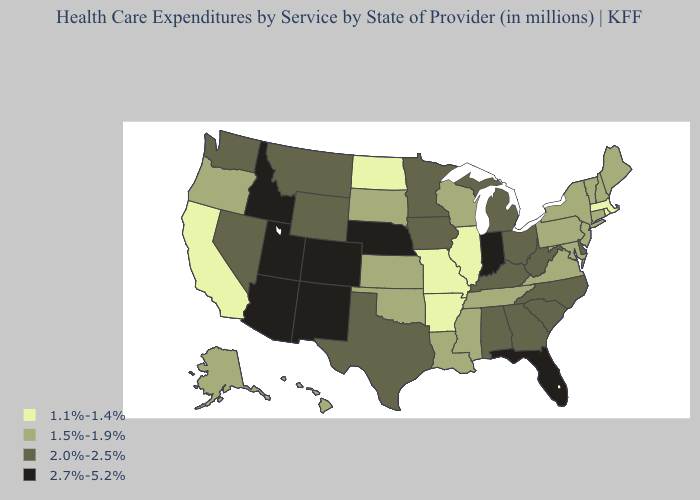Does Iowa have a lower value than Pennsylvania?
Write a very short answer. No. Does South Dakota have the lowest value in the USA?
Quick response, please. No. Does the map have missing data?
Keep it brief. No. Does the map have missing data?
Answer briefly. No. Name the states that have a value in the range 2.7%-5.2%?
Be succinct. Arizona, Colorado, Florida, Idaho, Indiana, Nebraska, New Mexico, Utah. Does Georgia have the lowest value in the South?
Keep it brief. No. Which states have the lowest value in the Northeast?
Answer briefly. Massachusetts, Rhode Island. What is the value of Rhode Island?
Quick response, please. 1.1%-1.4%. Among the states that border Georgia , does Tennessee have the highest value?
Give a very brief answer. No. What is the highest value in states that border Mississippi?
Keep it brief. 2.0%-2.5%. Name the states that have a value in the range 1.5%-1.9%?
Keep it brief. Alaska, Connecticut, Hawaii, Kansas, Louisiana, Maine, Maryland, Mississippi, New Hampshire, New Jersey, New York, Oklahoma, Oregon, Pennsylvania, South Dakota, Tennessee, Vermont, Virginia, Wisconsin. What is the value of Ohio?
Answer briefly. 2.0%-2.5%. What is the value of North Dakota?
Give a very brief answer. 1.1%-1.4%. What is the value of Pennsylvania?
Answer briefly. 1.5%-1.9%. Which states have the lowest value in the Northeast?
Be succinct. Massachusetts, Rhode Island. 